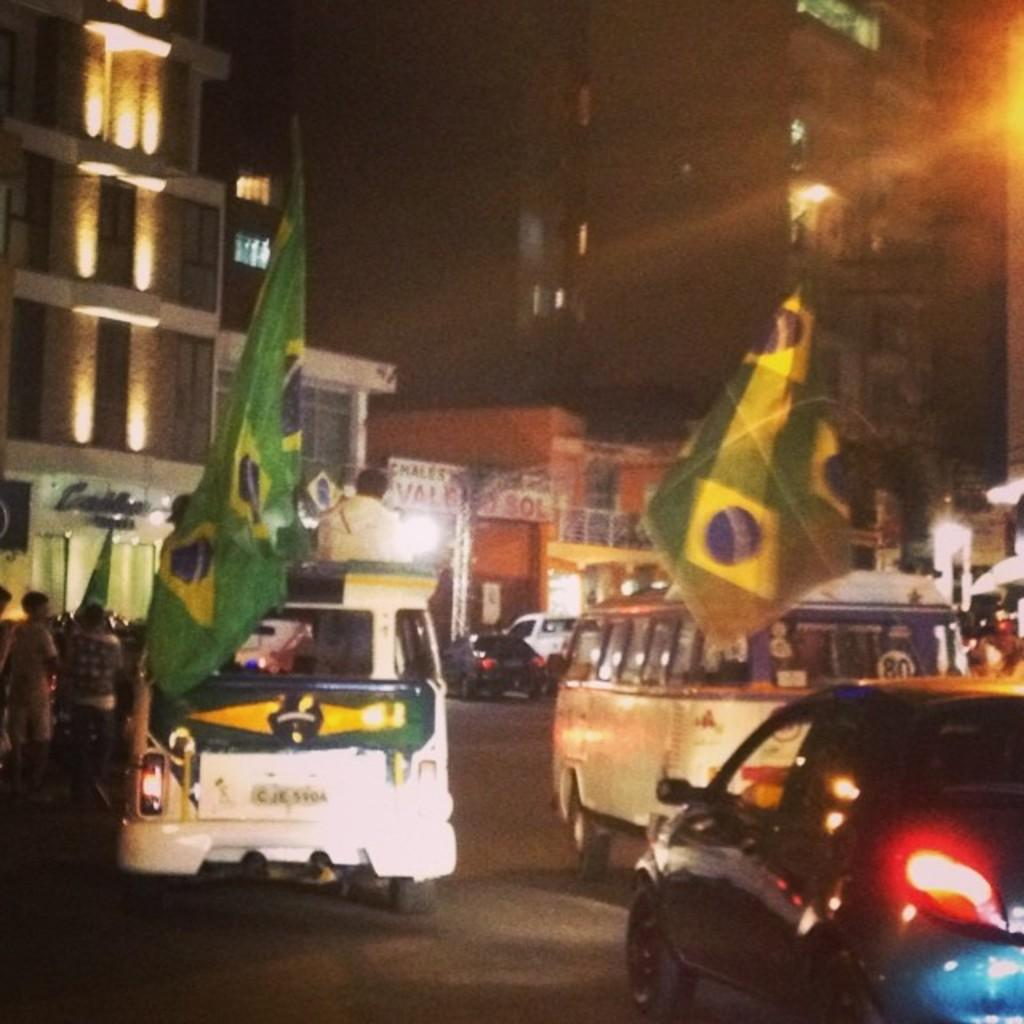<image>
Summarize the visual content of the image. some cars on the street with cje on them 